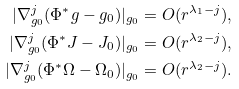<formula> <loc_0><loc_0><loc_500><loc_500>| \nabla _ { g _ { 0 } } ^ { j } ( \Phi ^ { * } g - g _ { 0 } ) | _ { g _ { 0 } } = O ( r ^ { \lambda _ { 1 } - j } ) , \\ | \nabla _ { g _ { 0 } } ^ { j } ( \Phi ^ { * } J - J _ { 0 } ) | _ { g _ { 0 } } = O ( r ^ { \lambda _ { 2 } - j } ) , \\ | \nabla _ { g _ { 0 } } ^ { j } ( \Phi ^ { * } \Omega - \Omega _ { 0 } ) | _ { g _ { 0 } } = O ( r ^ { \lambda _ { 2 } - j } ) .</formula> 